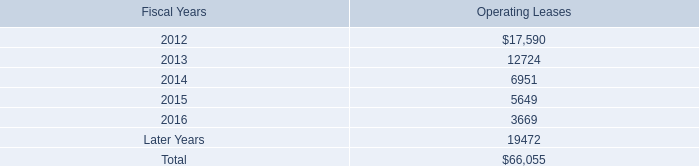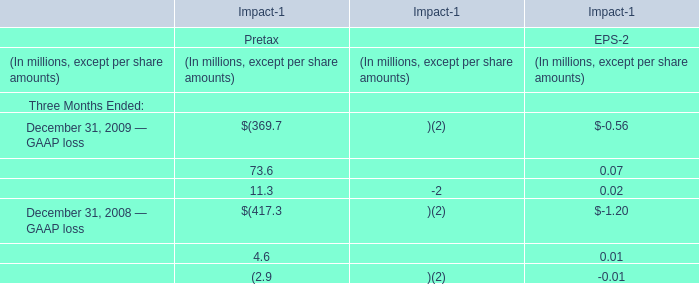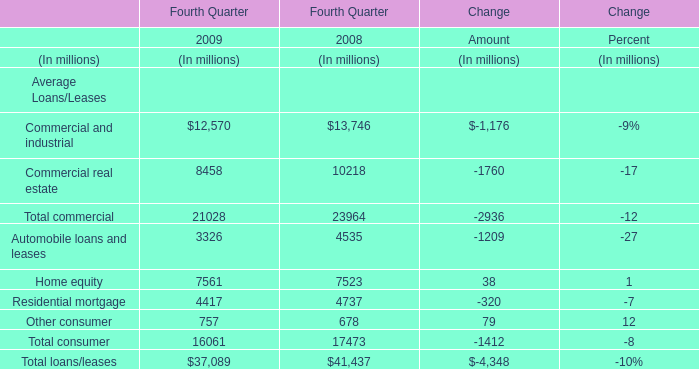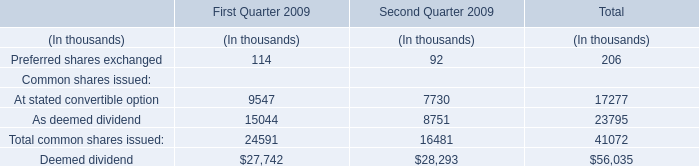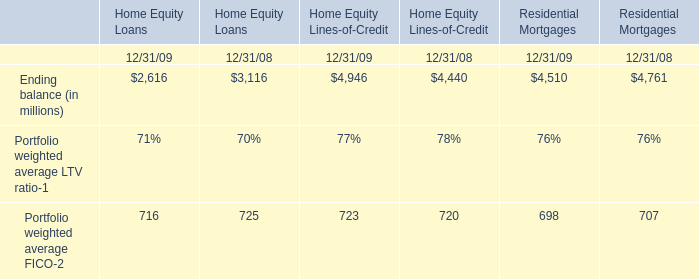what was the difference in percentage that total expenses changed between the us and non-us employees from 2009 to 2011? 
Computations: (((21.4 - 10.9) / 10.9) - ((21.9 - 21.5) / 21.5))
Answer: 0.9447. 